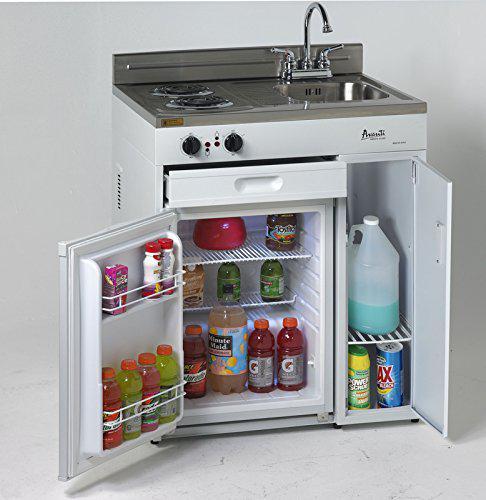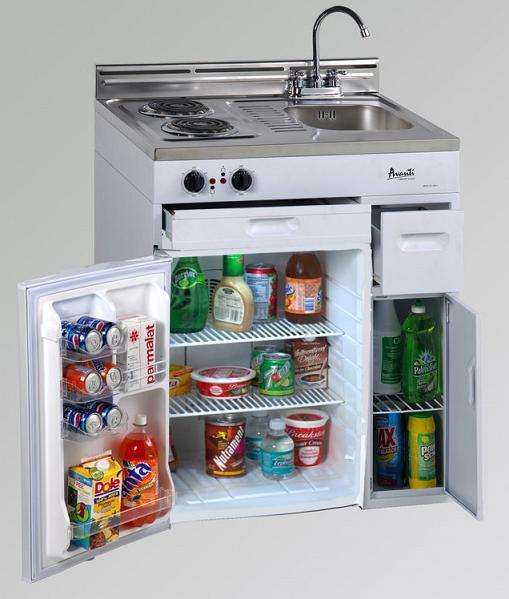The first image is the image on the left, the second image is the image on the right. For the images shown, is this caption "Both refrigerators have a side compartment." true? Answer yes or no. Yes. 